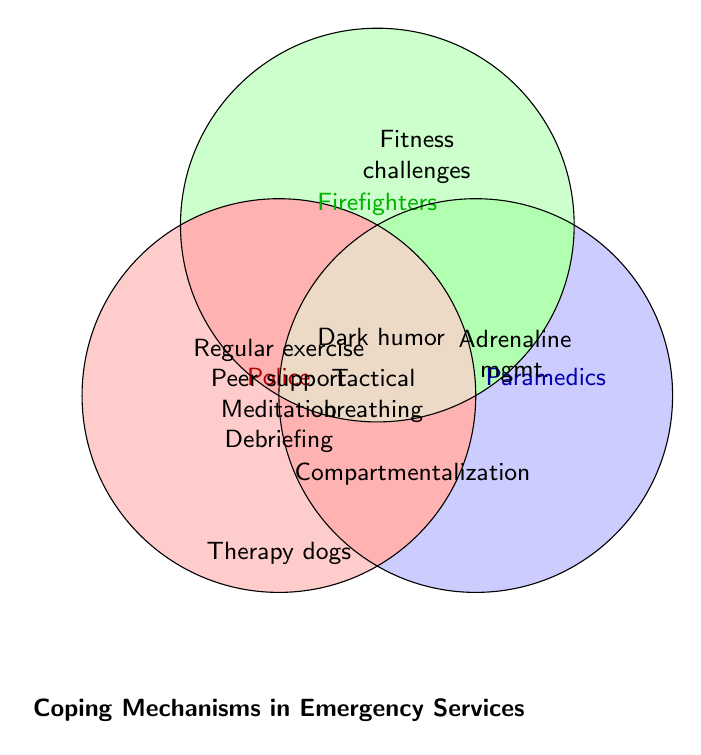What are the common coping mechanisms for stress shared by police, firefighters, and paramedics? The Venn Diagram shows the overlap of coping mechanisms among police, firefighters, and paramedics. The center of the diagram represents the mechanisms common to all three professions: Regular exercise, Peer support groups, Meditation, and Debriefing sessions.
Answer: Regular exercise, Peer support groups, Meditation, Debriefing sessions Which profession utilizes therapy dogs as a coping mechanism? The Venn Diagram indicates the unique coping mechanisms for each profession. Therapy dogs are listed uniquely under Police.
Answer: Police What coping mechanisms are common between police and firefighters but not paramedics? By looking at the overlapping area between Police and Firefighters but excluding the overlap with Paramedics, we see: Peer support groups, Regular exercise, Meditation, Debriefing sessions, Dark humor, and Compartmentalization. But since these all are already included everywhere, there are none specifically shared only by Police and Firefighters.
Answer: None Which profession has a unique coping mechanism of adrenaline management? The diagram shows unique mechanisms for each profession outside the overlapping areas. Adrenaline management is uniquely listed under Paramedics.
Answer: Paramedics How many unique coping mechanisms does the firefighter profession have that are not shared with the other professions? The Venn Diagram shows unique coping mechanisms outside of overlapping areas. Firefighters have Fire station camaraderie and Physical fitness challenges uniquely.
Answer: Two What coping mechanisms do police and paramedics share but not firefighters? The overlapping area between Police and Paramedics but excluding Firefighters shows Tactical breathing.
Answer: Tactical breathing Compare the use of dark humor among the three professions. Which ones use it? Dark humor is shown in overlapping areas of Police and Firefighters but absent in Paramedics' individual space. Therefore, Police and Firefighters use dark humor.
Answer: Police, Firefighters 